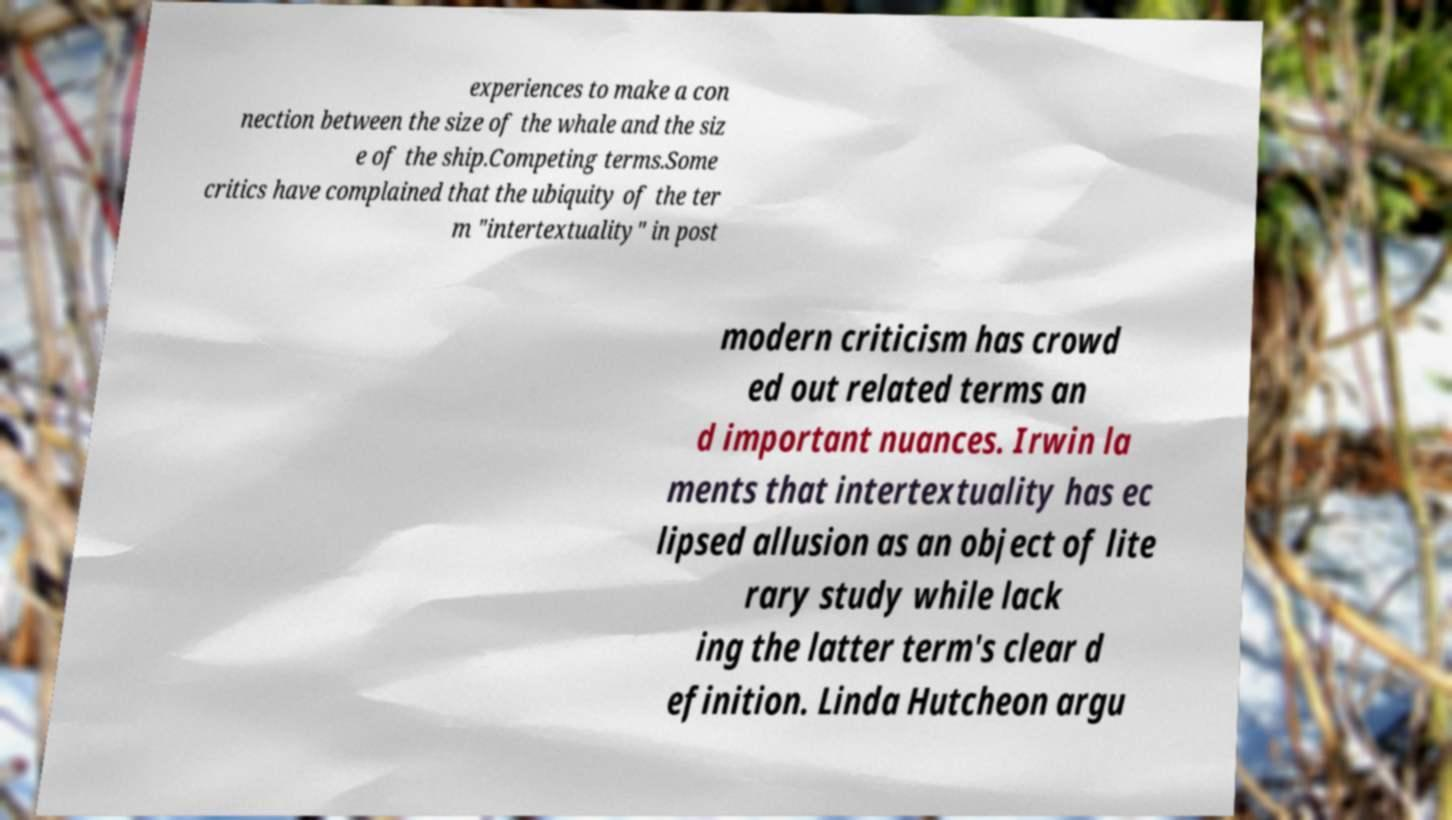Please identify and transcribe the text found in this image. experiences to make a con nection between the size of the whale and the siz e of the ship.Competing terms.Some critics have complained that the ubiquity of the ter m "intertextuality" in post modern criticism has crowd ed out related terms an d important nuances. Irwin la ments that intertextuality has ec lipsed allusion as an object of lite rary study while lack ing the latter term's clear d efinition. Linda Hutcheon argu 